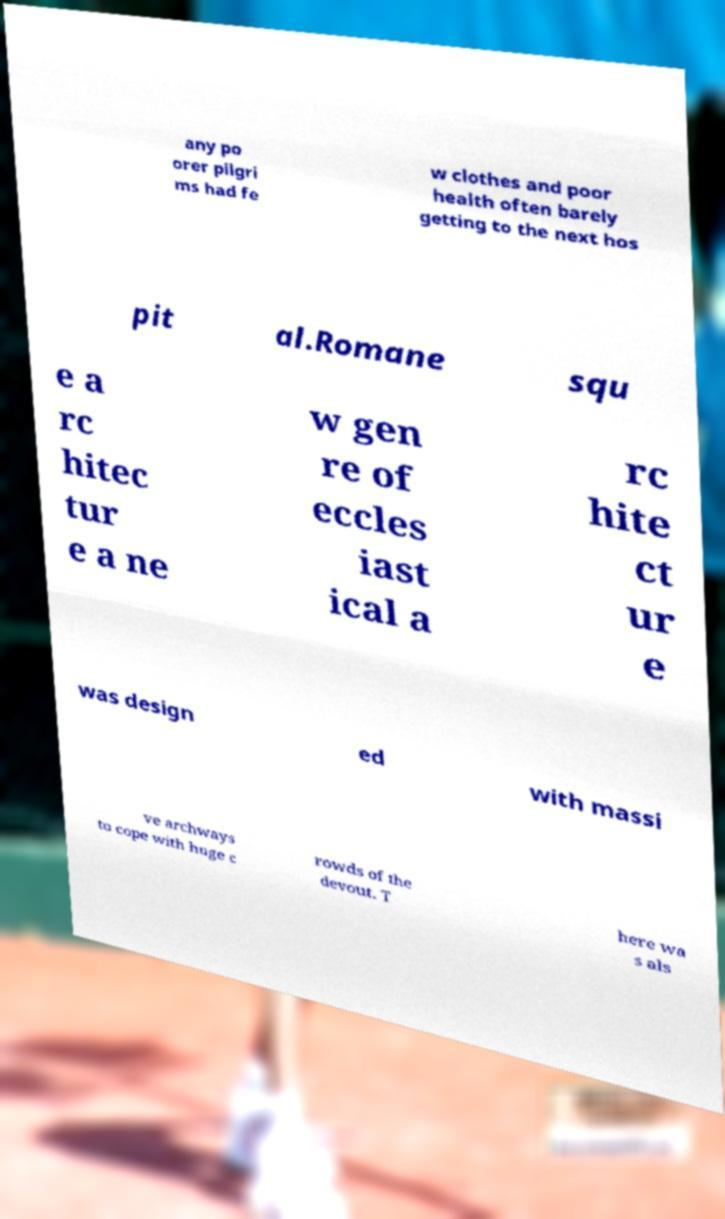Can you accurately transcribe the text from the provided image for me? any po orer pilgri ms had fe w clothes and poor health often barely getting to the next hos pit al.Romane squ e a rc hitec tur e a ne w gen re of eccles iast ical a rc hite ct ur e was design ed with massi ve archways to cope with huge c rowds of the devout. T here wa s als 